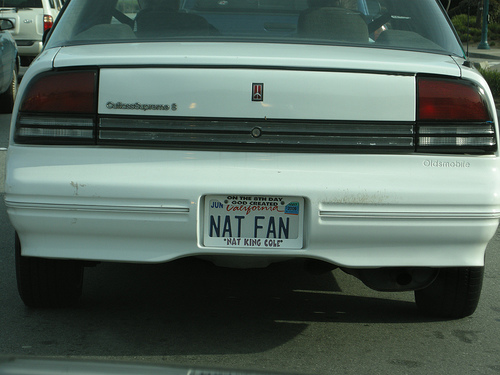<image>
Is the bumper on the street? No. The bumper is not positioned on the street. They may be near each other, but the bumper is not supported by or resting on top of the street. 